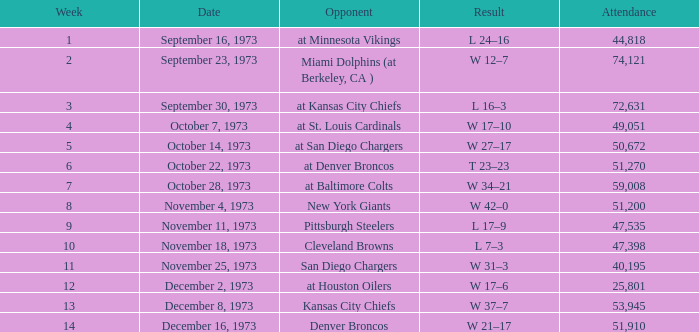What was the crowd size at the game against the kansas city chiefs earlier than week 13? None. 